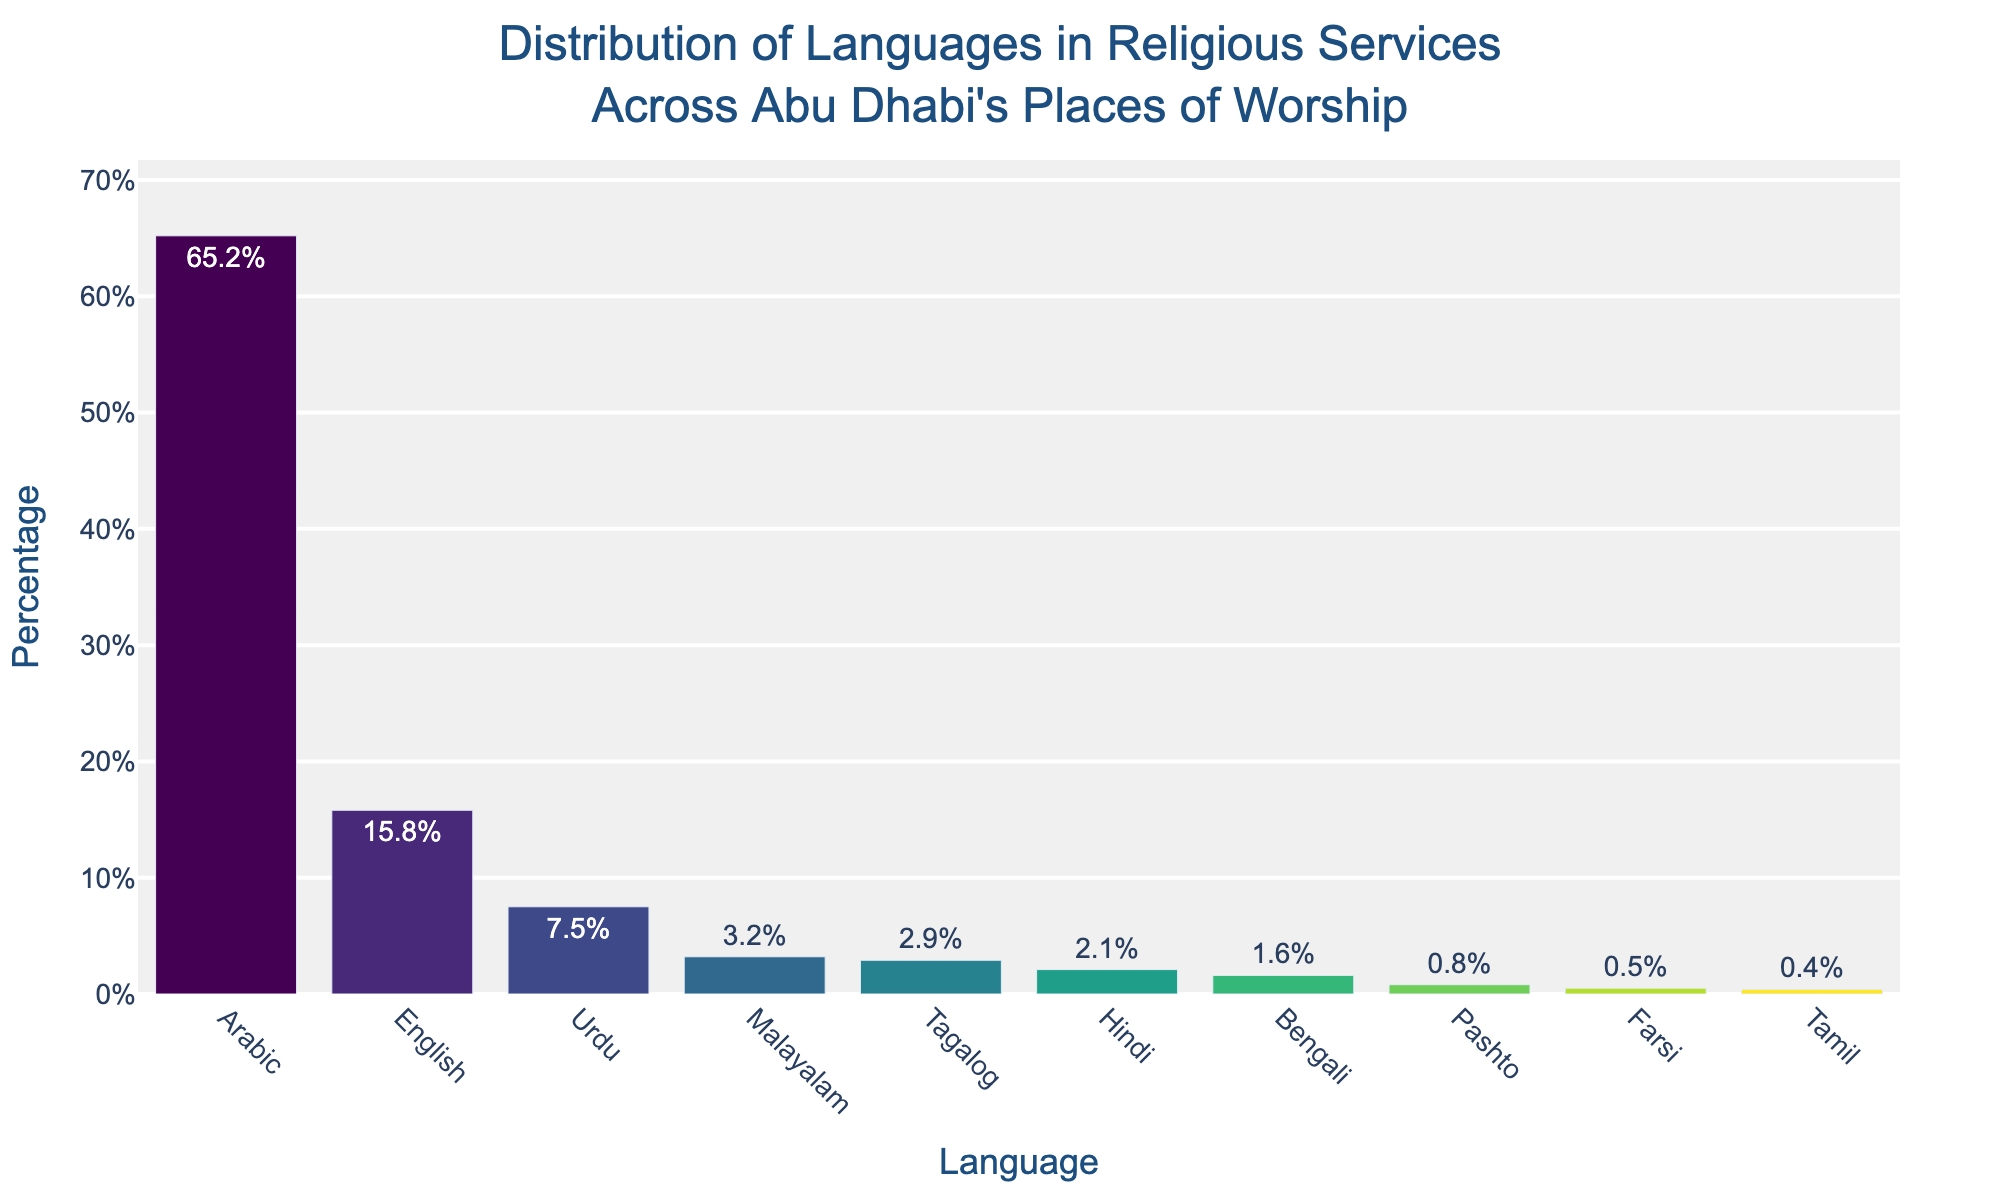What language is used the most in religious services in Abu Dhabi's places of worship? The bar chart shows that Arabic has the highest percentage among all languages used in religious services.
Answer: Arabic Which language is used less frequently, Urdu or Malayalam? From the bar chart, it is clear that Urdu has a higher percentage (7.5%) compared to Malayalam (3.2%).
Answer: Malayalam What is the combined percentage of religious services conducted in Tagalog and Hindi? The percentage for Tagalog is 2.9% and for Hindi is 2.1%. Adding them together gives 2.9% + 2.1% = 5.0%.
Answer: 5.0% How does the usage of English in religious services compare to Bengali? The chart lists English at 15.8% and Bengali at 1.6%. Comparing these values, English has a much higher percentage than Bengali.
Answer: English is higher What percentage of religious services are conducted in languages other than Arabic and English? Sum the percentages of all languages except Arabic (65.2%) and English (15.8%): 7.5% + 3.2% + 2.9% + 2.1% + 1.6% + 0.8% + 0.5% + 0.4% = 19.0%.
Answer: 19.0% Which language is used least frequently, and what percentage of services does it represent? The language with the lowest bar height represents Tamil, with a percentage of 0.4%.
Answer: Tamil, 0.4% Is the percentage of religious services conducted in Urdu more than double that of Malayalam? The percentage for Urdu is 7.5%, and for Malayalam, it is 3.2%. Doubling the percentage of Malayalam gives 3.2% * 2 = 6.4%, which is less than 7.5%.
Answer: Yes What's the average percentage of services conducted in Pashto, Farsi, and Tamil? Sum the percentages: 0.8% + 0.5% + 0.4% = 1.7%. Divide by 3 to find the average: 1.7% / 3 = 0.567%.
Answer: 0.567% Which two languages have a combined percentage closest to 10%? Sum combinations to find the closest: Urdu (7.5%) + Malayalam (3.2%) = 10.7%, Urdu (7.5%) + Tagalog (2.9%) = 10.4%. The combination of Urdu and Tagalog (10.4%) is closest to 10%.
Answer: Urdu and Tagalog How many languages have a percentage lower than 1%? The chart shows the bars for Pashto (0.8%), Farsi (0.5%), and Tamil (0.4%), making 3 languages below 1%.
Answer: 3 